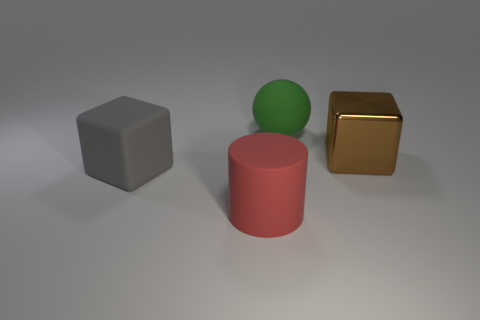Add 2 red rubber balls. How many objects exist? 6 Subtract all balls. How many objects are left? 3 Subtract 0 green blocks. How many objects are left? 4 Subtract all purple blocks. Subtract all purple cylinders. How many blocks are left? 2 Subtract all red cubes. How many brown cylinders are left? 0 Subtract all tiny blue shiny balls. Subtract all big brown shiny blocks. How many objects are left? 3 Add 3 red rubber cylinders. How many red rubber cylinders are left? 4 Add 1 green things. How many green things exist? 2 